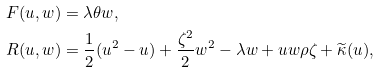<formula> <loc_0><loc_0><loc_500><loc_500>F ( u , w ) & = \lambda \theta w , \\ R ( u , w ) & = \frac { 1 } { 2 } ( u ^ { 2 } - u ) + \frac { \zeta ^ { 2 } } { 2 } w ^ { 2 } - \lambda w + u w \rho \zeta + \widetilde { \kappa } ( u ) ,</formula> 